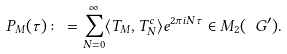Convert formula to latex. <formula><loc_0><loc_0><loc_500><loc_500>P _ { M } ( \tau ) \colon = \sum _ { N = 0 } ^ { \infty } \langle T _ { M } , T _ { N } ^ { c } \rangle e ^ { 2 \pi i N \tau } \in M _ { 2 } ( \ G ^ { \prime } ) .</formula> 